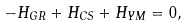<formula> <loc_0><loc_0><loc_500><loc_500>- H _ { G R } + H _ { C S } + H _ { Y M } = 0 ,</formula> 